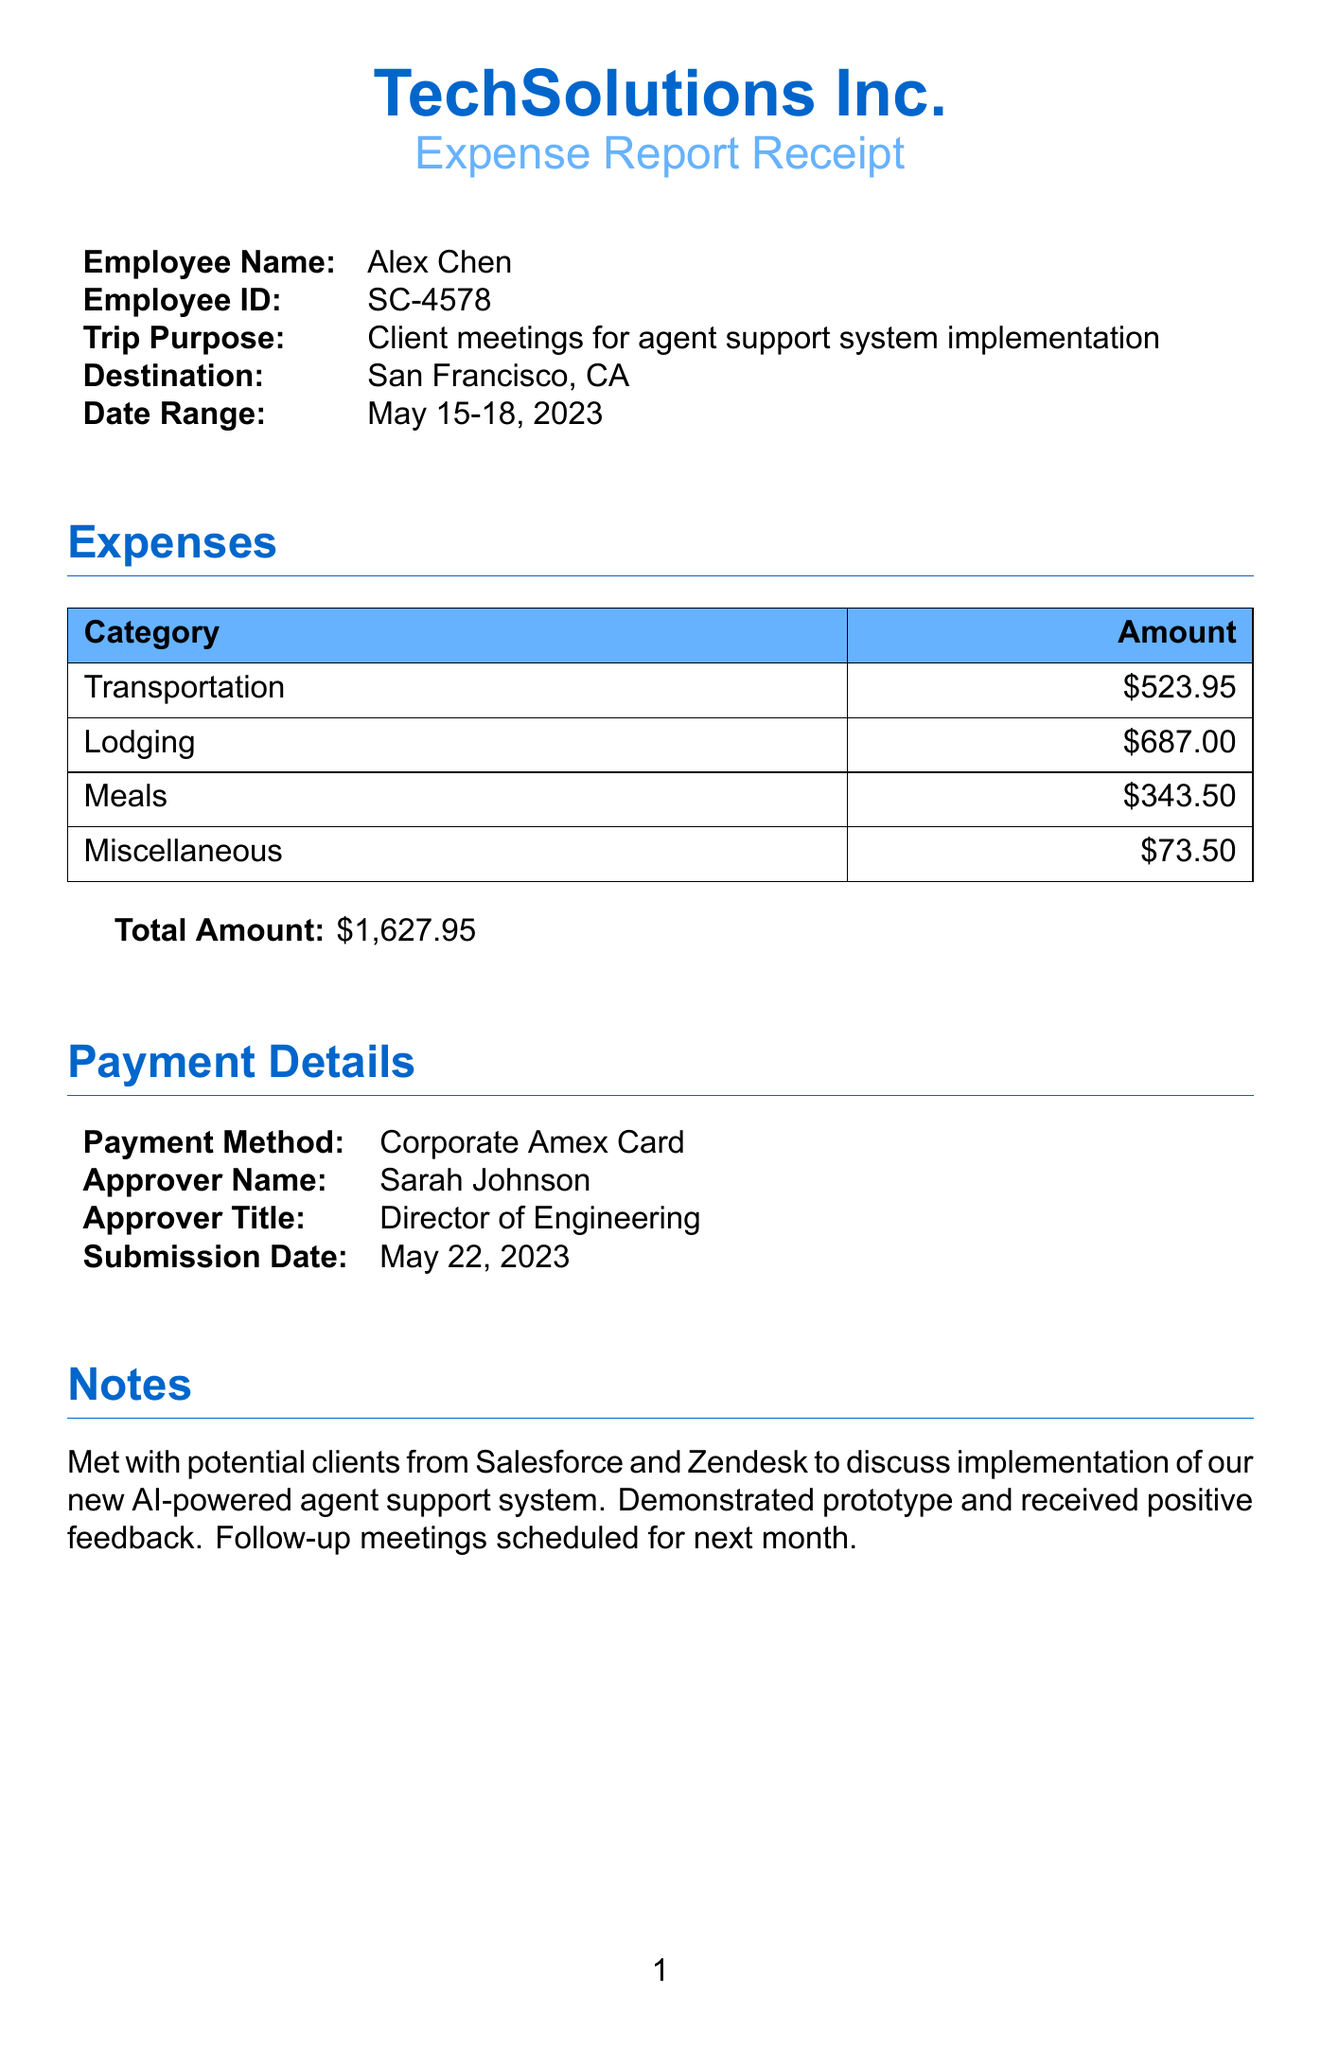what is the employee name? The employee name is mentioned in the document under employee details.
Answer: Alex Chen what is the total amount of expenses? The total amount is the sum of all expenses listed in the document.
Answer: $1,627.95 what is the destination of the trip? The destination is stated in the trip details section of the document.
Answer: San Francisco, CA how many nights was the lodging? The lodging details indicate the duration of the stay at the hotel.
Answer: 3 nights who is the approver of the expense report? The approver's name is provided in the payment details section.
Answer: Sarah Johnson what was the trip purpose? The purpose of the trip is specified in the employee details section.
Answer: Client meetings for agent support system implementation how much was spent on meals? The meals expense category shows the total spent on meals during the trip.
Answer: $343.50 which vendor provided the lodging? The lodging vendor is listed in the lodging expenses.
Answer: Hilton Hotels what type of payment method was used? The payment method is stated in the payment details section of the document.
Answer: Corporate Amex Card 